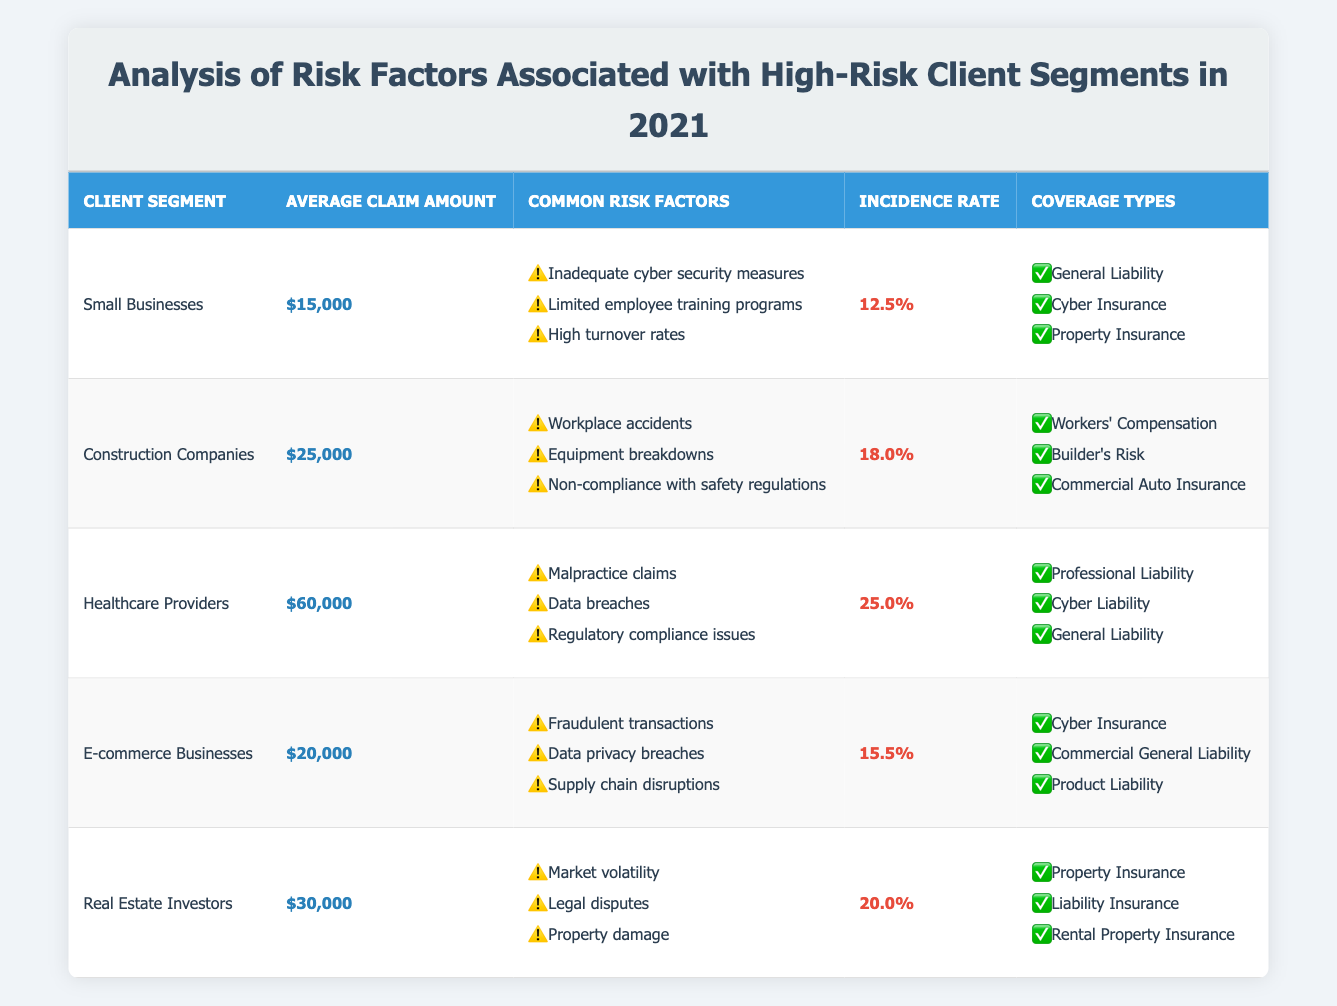What is the average claim amount for Healthcare Providers? According to the table, the average claim amount for Healthcare Providers is listed directly as $60,000.
Answer: $60,000 Which client segment has the highest incidence rate? The incidence rates for the client segments are listed as 12.5% for Small Businesses, 18.0% for Construction Companies, 25.0% for Healthcare Providers, 15.5% for E-commerce Businesses, and 20.0% for Real Estate Investors. The highest is 25.0% for Healthcare Providers.
Answer: Healthcare Providers Are fraud-related risk factors common for Small Businesses? The common risk factors for Small Businesses include inadequate cyber security measures, limited employee training programs, and high turnover rates. Fraud-related issues are not mentioned. Thus, the answer is no.
Answer: No What is the average claim amount for Construction Companies and Real Estate Investors combined? The average claim amount for Construction Companies is $25,000, and for Real Estate Investors, it is $30,000. Adding them gives $25,000 + $30,000 = $55,000. Since there are two segments, divide by 2 to get the average: $55,000 / 2 = $27,500.
Answer: $27,500 What common risk factors are associated with E-commerce Businesses? The table lists the common risk factors for E-commerce Businesses as fraudulent transactions, data privacy breaches, and supply chain disruptions. This information can be found directly under that segment.
Answer: Fraudulent transactions, data privacy breaches, supply chain disruptions True or False: Workers' Compensation is a coverage type for Small Businesses. According to the table, the coverage types for Small Businesses include General Liability, Cyber Insurance, and Property Insurance, but not Workers' Compensation, which is specific to Construction Companies.
Answer: False Which client segment has a higher average claim amount: E-commerce Businesses or Small Businesses? The average claim amount for E-commerce Businesses is $20,000, while for Small Businesses it is $15,000. Since $20,000 is greater than $15,000, E-commerce Businesses have a higher claim amount.
Answer: E-commerce Businesses What is the incidence rate difference between Healthcare Providers and Real Estate Investors? The incidence rate for Healthcare Providers is 25.0% and for Real Estate Investors it is 20.0%. To find the difference, subtract the lower rate from the higher rate: 25.0% - 20.0% = 5.0%.
Answer: 5.0% 